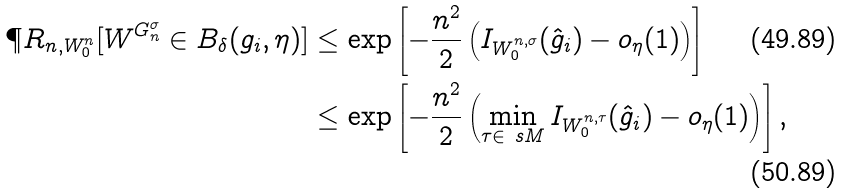Convert formula to latex. <formula><loc_0><loc_0><loc_500><loc_500>\P R _ { n , W _ { 0 } ^ { n } } [ W ^ { G _ { n } ^ { \sigma } } \in B _ { \delta } ( g _ { i } , \eta ) ] & \leq \exp \left [ - \frac { n ^ { 2 } } { 2 } \left ( I _ { W _ { 0 } ^ { n , \sigma } } ( \hat { g } _ { i } ) - o _ { \eta } ( 1 ) \right ) \right ] \\ & \leq \exp \left [ - \frac { n ^ { 2 } } { 2 } \left ( \min _ { \tau \in \ s M } I _ { W _ { 0 } ^ { n , \tau } } ( \hat { g } _ { i } ) - o _ { \eta } ( 1 ) \right ) \right ] ,</formula> 